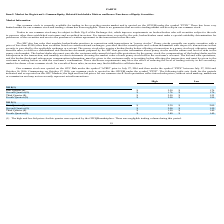According to Protagenic Therapeutics's financial document, How did the company obtain the high and low bid prices for each quarter? Reported by the OTCQB marketplace.. The document states: "The high and low bid prices for this quarter were reported by the OTCQB marketplace. There was negligible trading volume during this period. 19..." Also, What is the company's common stock traded as on the OTCQB? According to the financial document, PTIX. The relevant text states: "rket and is quoted on the OTCQB under the symbol “PTIX.” There has been very..." Also, What was symbol of the company's common stock quoted on the OTC Pink quoted as prior to July 27, 2016? According to the financial document, ATRN. The relevant text states: "tock was quoted on the OTC Pink under the symbol “ATRN” prior to July 27, 2016 and then under the symbol “PTIX” between July 27, 2016 and..." Also, can you calculate: What is the difference between the highest and lowest bid price in 2018? Based on the calculation: 2.50 - 1.25 , the result is 1.25. This is based on the information: "Third Quarter (1) $ 2.50 $ 1.25 Third Quarter (1) $ 2.50 $ 1.25..." The key data points involved are: 2.50. Also, can you calculate: What is the difference between the highest and lowest bid price in 2019? Based on the calculation: 3.80 - 1.40 , the result is 2.4. This is based on the information: "Third Quarter (1) $ 1.50 $ 1.40 Fourth Quarter (1) $ 3.80 $ 1.40..." The key data points involved are: 1.40, 3.80. Also, can you calculate: What is the low bid price in the second quarter of 2019 as a percentage of the high bid price in the same period? Based on the calculation: 1.5/2 , the result is 75 (percentage). This is based on the information: "Second Quarter (1) $ 2.00 $ 1.50 Second Quarter (1) $ 2.00 $ 1.50..." The key data points involved are: 1.5, 2. 